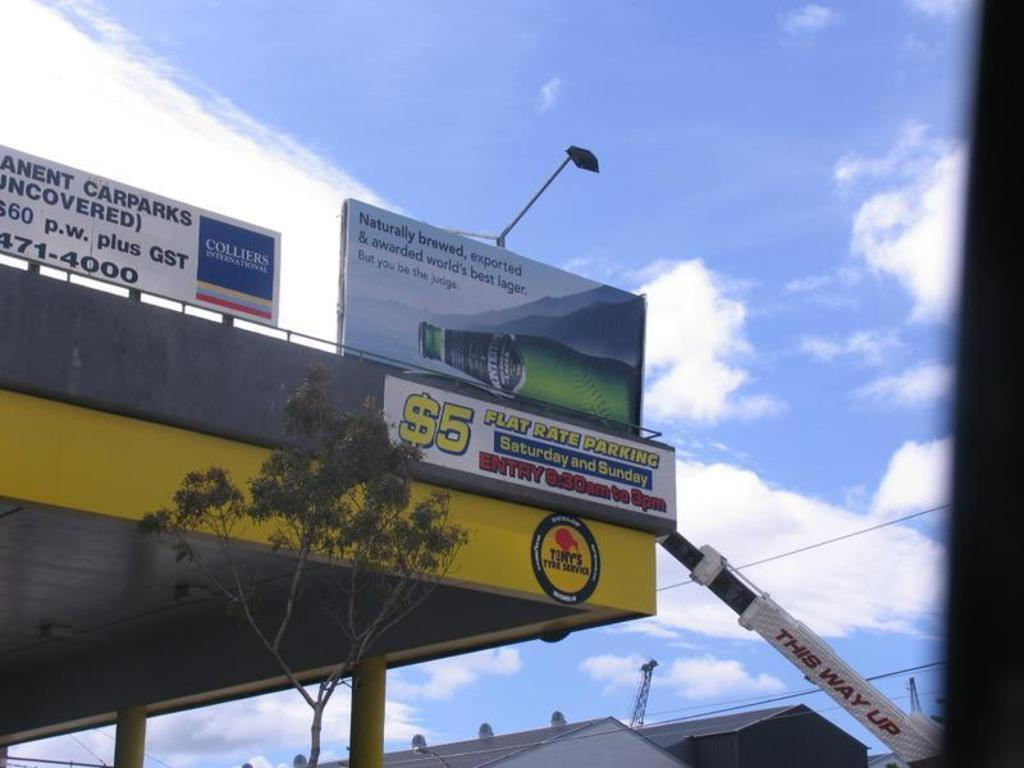<image>
Offer a succinct explanation of the picture presented. Advertisement on top of an awning on Colliers International and Flat Rate Parking 5 dollars on Saturday and Sunday. 